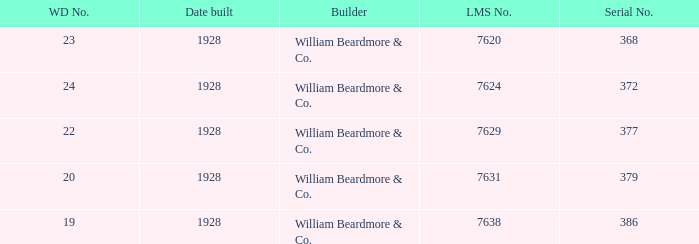Name the total number of wd number for lms number being 7638 1.0. 